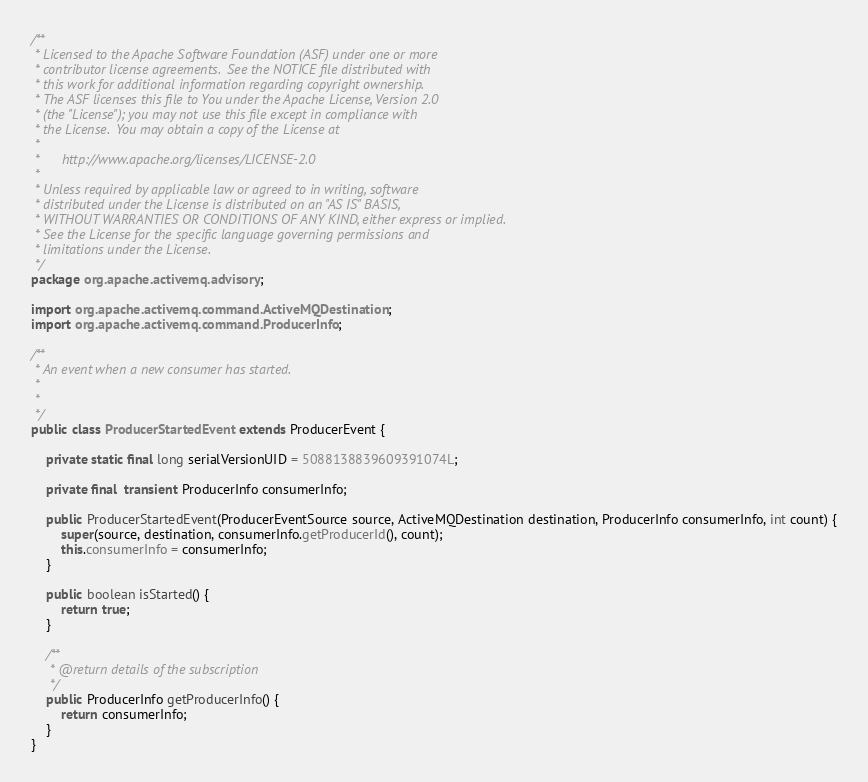Convert code to text. <code><loc_0><loc_0><loc_500><loc_500><_Java_>/**
 * Licensed to the Apache Software Foundation (ASF) under one or more
 * contributor license agreements.  See the NOTICE file distributed with
 * this work for additional information regarding copyright ownership.
 * The ASF licenses this file to You under the Apache License, Version 2.0
 * (the "License"); you may not use this file except in compliance with
 * the License.  You may obtain a copy of the License at
 *
 *      http://www.apache.org/licenses/LICENSE-2.0
 *
 * Unless required by applicable law or agreed to in writing, software
 * distributed under the License is distributed on an "AS IS" BASIS,
 * WITHOUT WARRANTIES OR CONDITIONS OF ANY KIND, either express or implied.
 * See the License for the specific language governing permissions and
 * limitations under the License.
 */
package org.apache.activemq.advisory;

import org.apache.activemq.command.ActiveMQDestination;
import org.apache.activemq.command.ProducerInfo;

/**
 * An event when a new consumer has started.
 * 
 * 
 */
public class ProducerStartedEvent extends ProducerEvent {

    private static final long serialVersionUID = 5088138839609391074L;

    private final  transient ProducerInfo consumerInfo;

    public ProducerStartedEvent(ProducerEventSource source, ActiveMQDestination destination, ProducerInfo consumerInfo, int count) {
        super(source, destination, consumerInfo.getProducerId(), count);
        this.consumerInfo = consumerInfo;
    }

    public boolean isStarted() {
        return true;
    }

    /**
     * @return details of the subscription
     */
    public ProducerInfo getProducerInfo() {
        return consumerInfo;
    }
}
</code> 